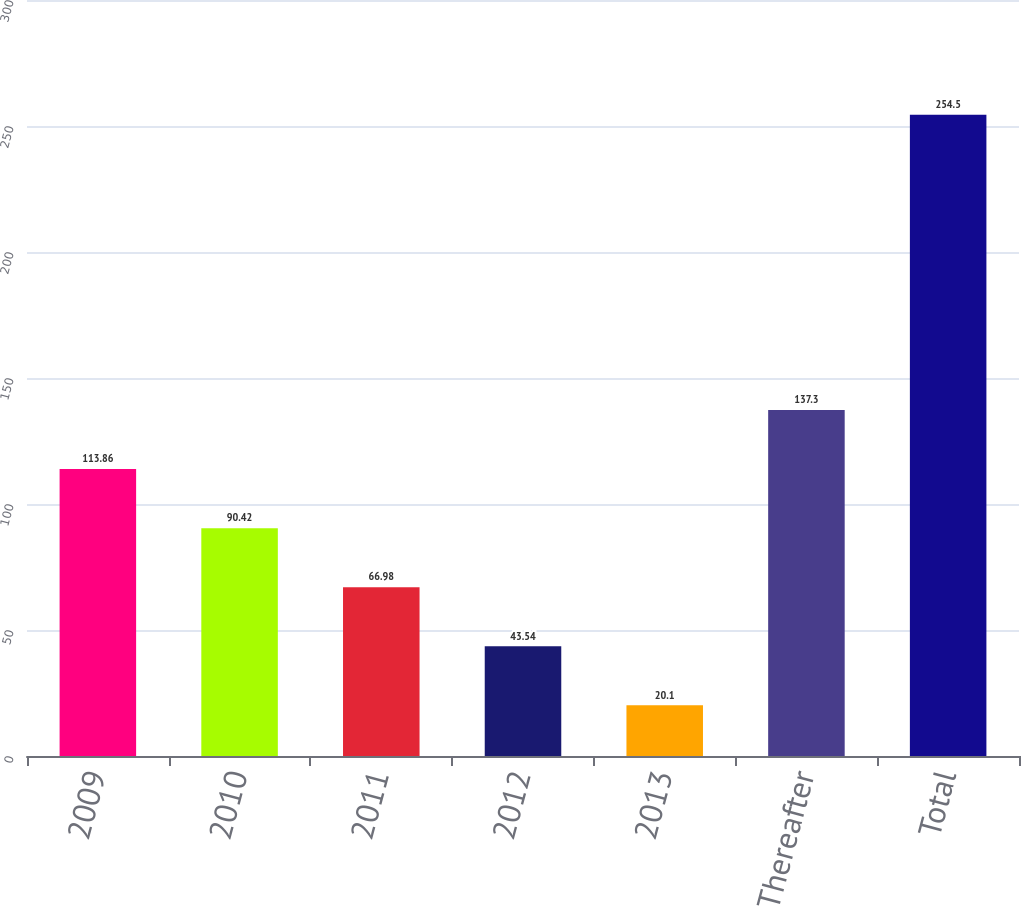Convert chart. <chart><loc_0><loc_0><loc_500><loc_500><bar_chart><fcel>2009<fcel>2010<fcel>2011<fcel>2012<fcel>2013<fcel>Thereafter<fcel>Total<nl><fcel>113.86<fcel>90.42<fcel>66.98<fcel>43.54<fcel>20.1<fcel>137.3<fcel>254.5<nl></chart> 